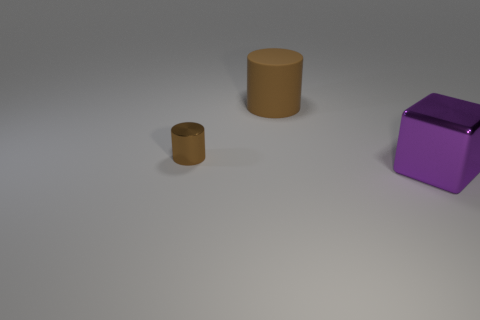Add 1 large yellow metal cylinders. How many objects exist? 4 Subtract all blocks. How many objects are left? 2 Subtract 2 cylinders. How many cylinders are left? 0 Subtract 0 red cylinders. How many objects are left? 3 Subtract all gray cubes. Subtract all yellow balls. How many cubes are left? 1 Subtract all yellow shiny blocks. Subtract all big rubber objects. How many objects are left? 2 Add 1 tiny cylinders. How many tiny cylinders are left? 2 Add 2 purple metal blocks. How many purple metal blocks exist? 3 